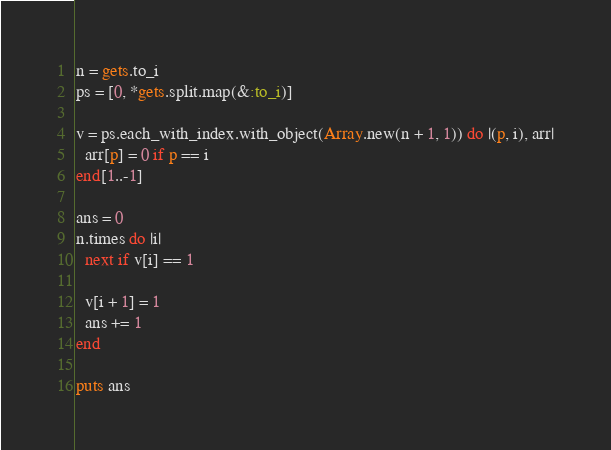<code> <loc_0><loc_0><loc_500><loc_500><_Ruby_>n = gets.to_i
ps = [0, *gets.split.map(&:to_i)]

v = ps.each_with_index.with_object(Array.new(n + 1, 1)) do |(p, i), arr|
  arr[p] = 0 if p == i
end[1..-1]

ans = 0
n.times do |i|
  next if v[i] == 1

  v[i + 1] = 1
  ans += 1
end

puts ans
</code> 